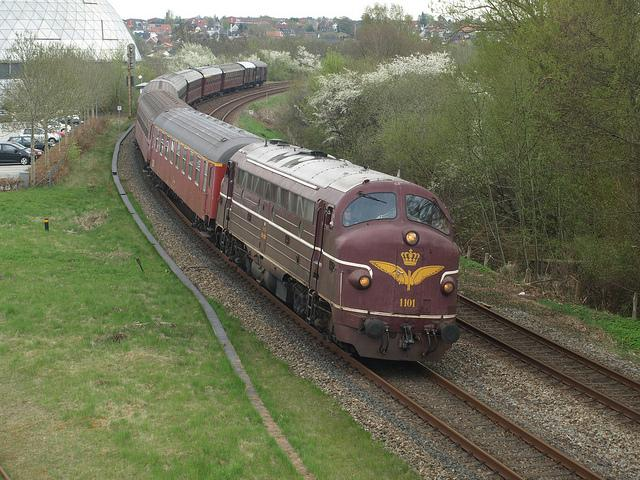What wrestler is named after the long item with the wing logo? hawk 